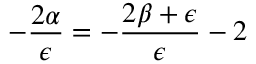<formula> <loc_0><loc_0><loc_500><loc_500>- \frac { 2 \alpha } { \epsilon } = - \frac { 2 \beta + \epsilon } { \epsilon } - 2</formula> 